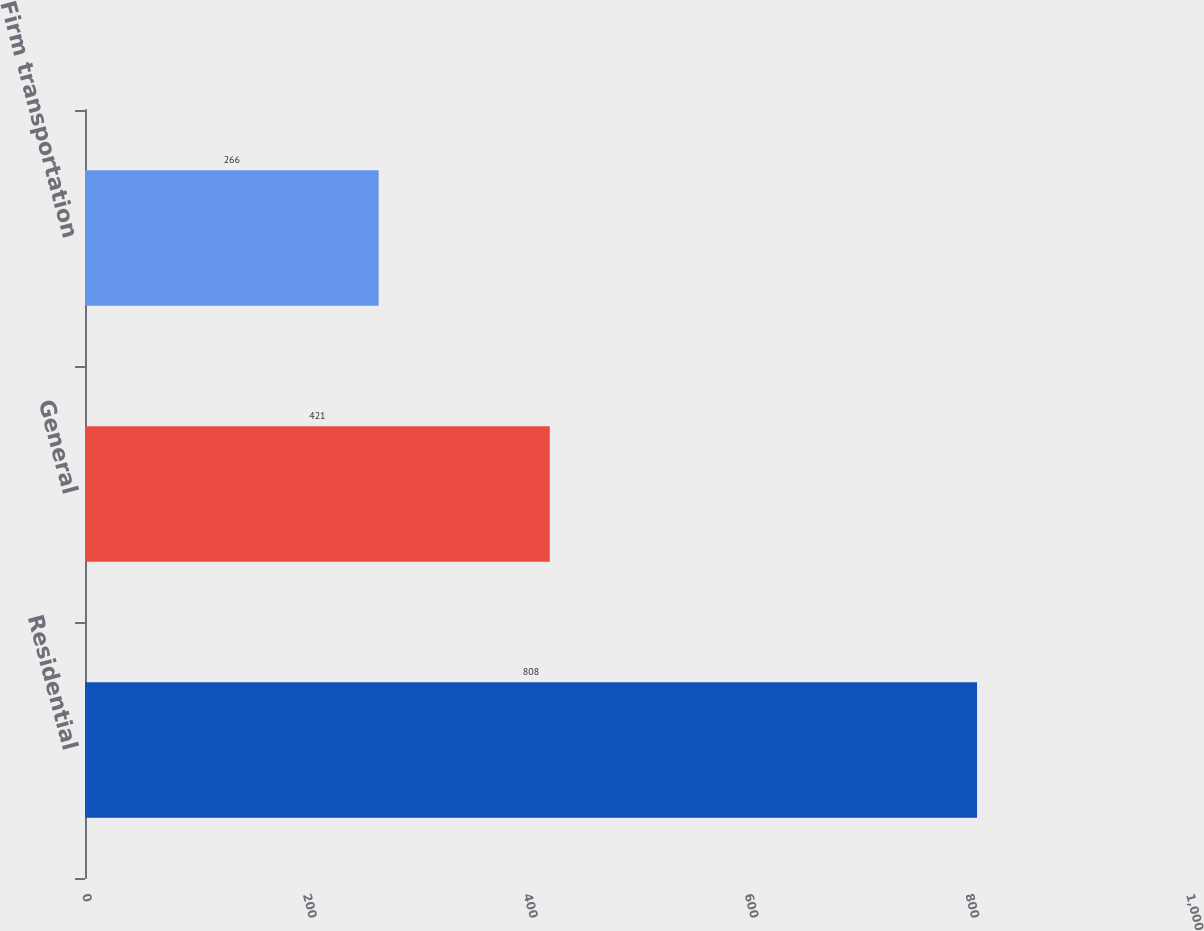Convert chart to OTSL. <chart><loc_0><loc_0><loc_500><loc_500><bar_chart><fcel>Residential<fcel>General<fcel>Firm transportation<nl><fcel>808<fcel>421<fcel>266<nl></chart> 